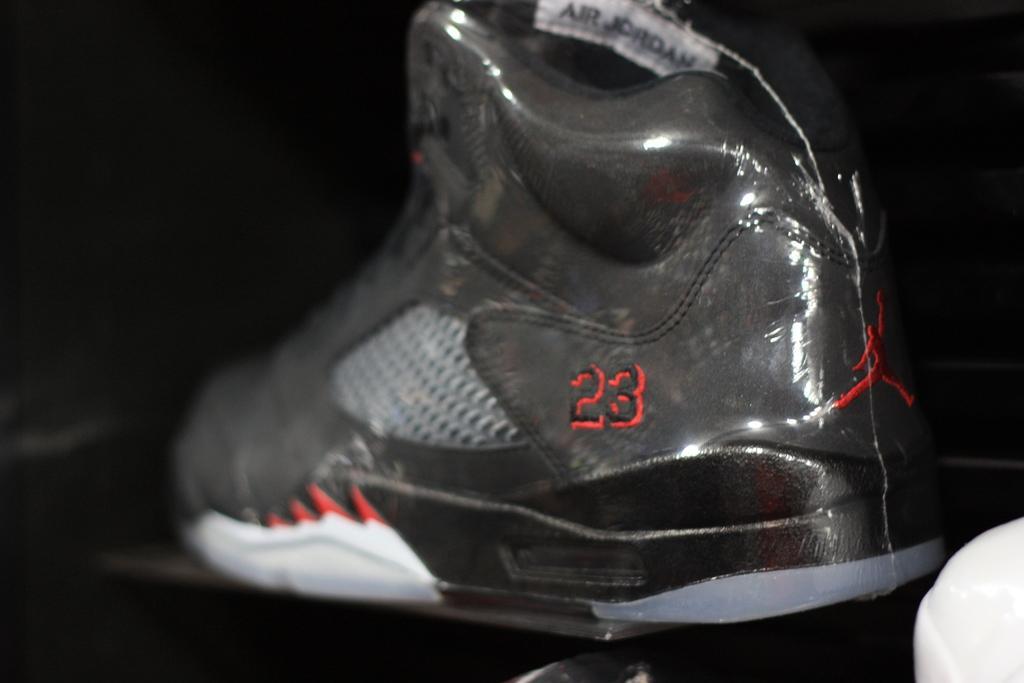Could you give a brief overview of what you see in this image? In this image we can see one shoe on the table, some objects on the floor and there is a black background. 